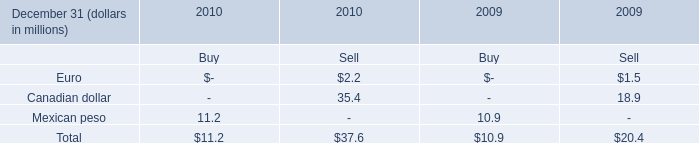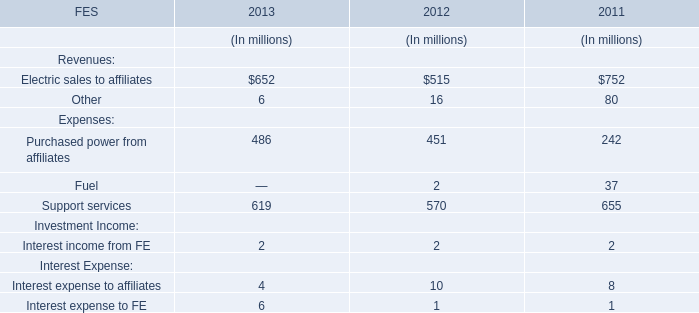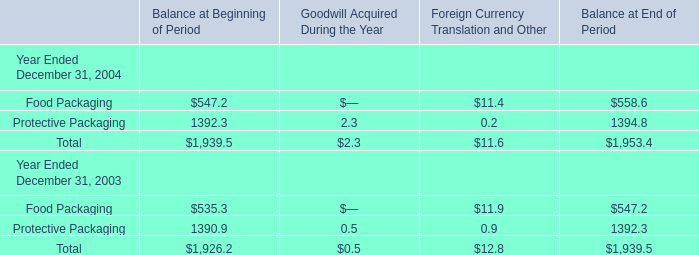What is the sum of Electric sales to affiliates in 2013 and Total in 2010 for Buy ? 
Computations: (652 + 11.2)
Answer: 663.2. 